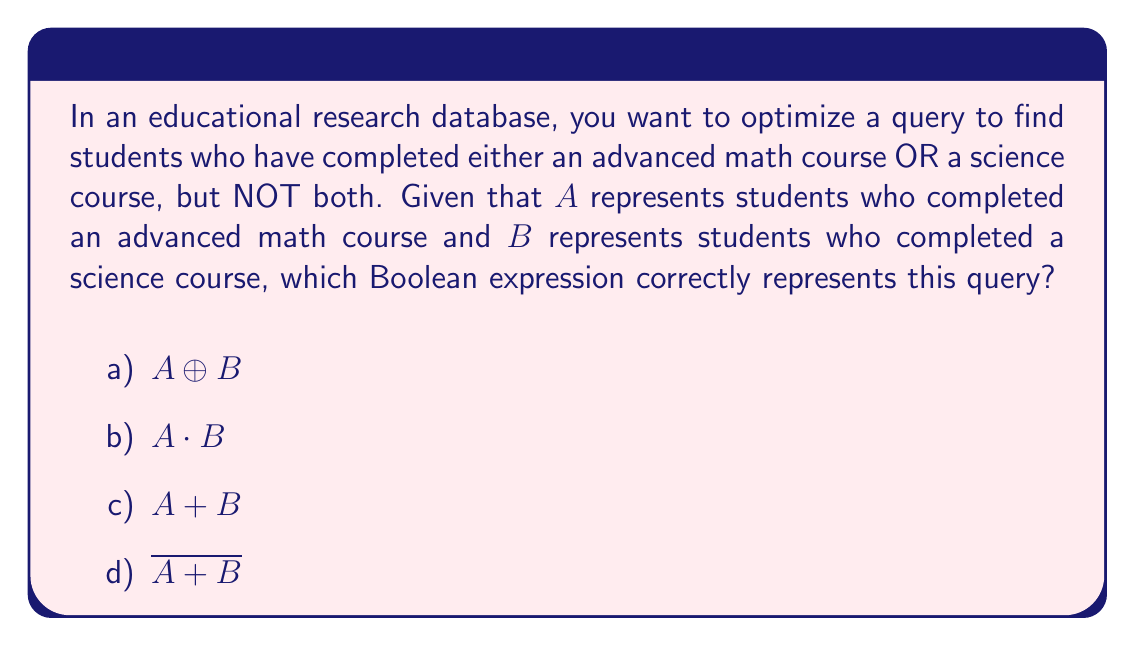Provide a solution to this math problem. Let's approach this step-by-step:

1) We need students who have completed either math OR science, but not both. This is the definition of the exclusive OR (XOR) operation.

2) In Boolean algebra, the XOR operation is represented by the symbol $\oplus$.

3) The XOR operation ($A \oplus B$) is true when either $A$ is true or $B$ is true, but not when both are true or both are false.

4) Let's evaluate each option:

   a) $A \oplus B$: This is the XOR operation, which matches our requirements.
   
   b) $A \cdot B$: This represents the AND operation, which would give us students who completed both math AND science. This doesn't meet our criteria.
   
   c) $A + B$: This represents the OR operation, which would include students who completed both subjects, violating our "not both" condition.
   
   d) $\overline{A + B}$: This is the NOR operation, which would give us students who completed neither math nor science, not meeting our criteria.

5) Therefore, the correct Boolean expression to optimize this database query is $A \oplus B$.

This query would efficiently filter the database to return only the students who have completed either an advanced math course or a science course, but not both, which is crucial for certain types of educational research and analysis.
Answer: $A \oplus B$ 